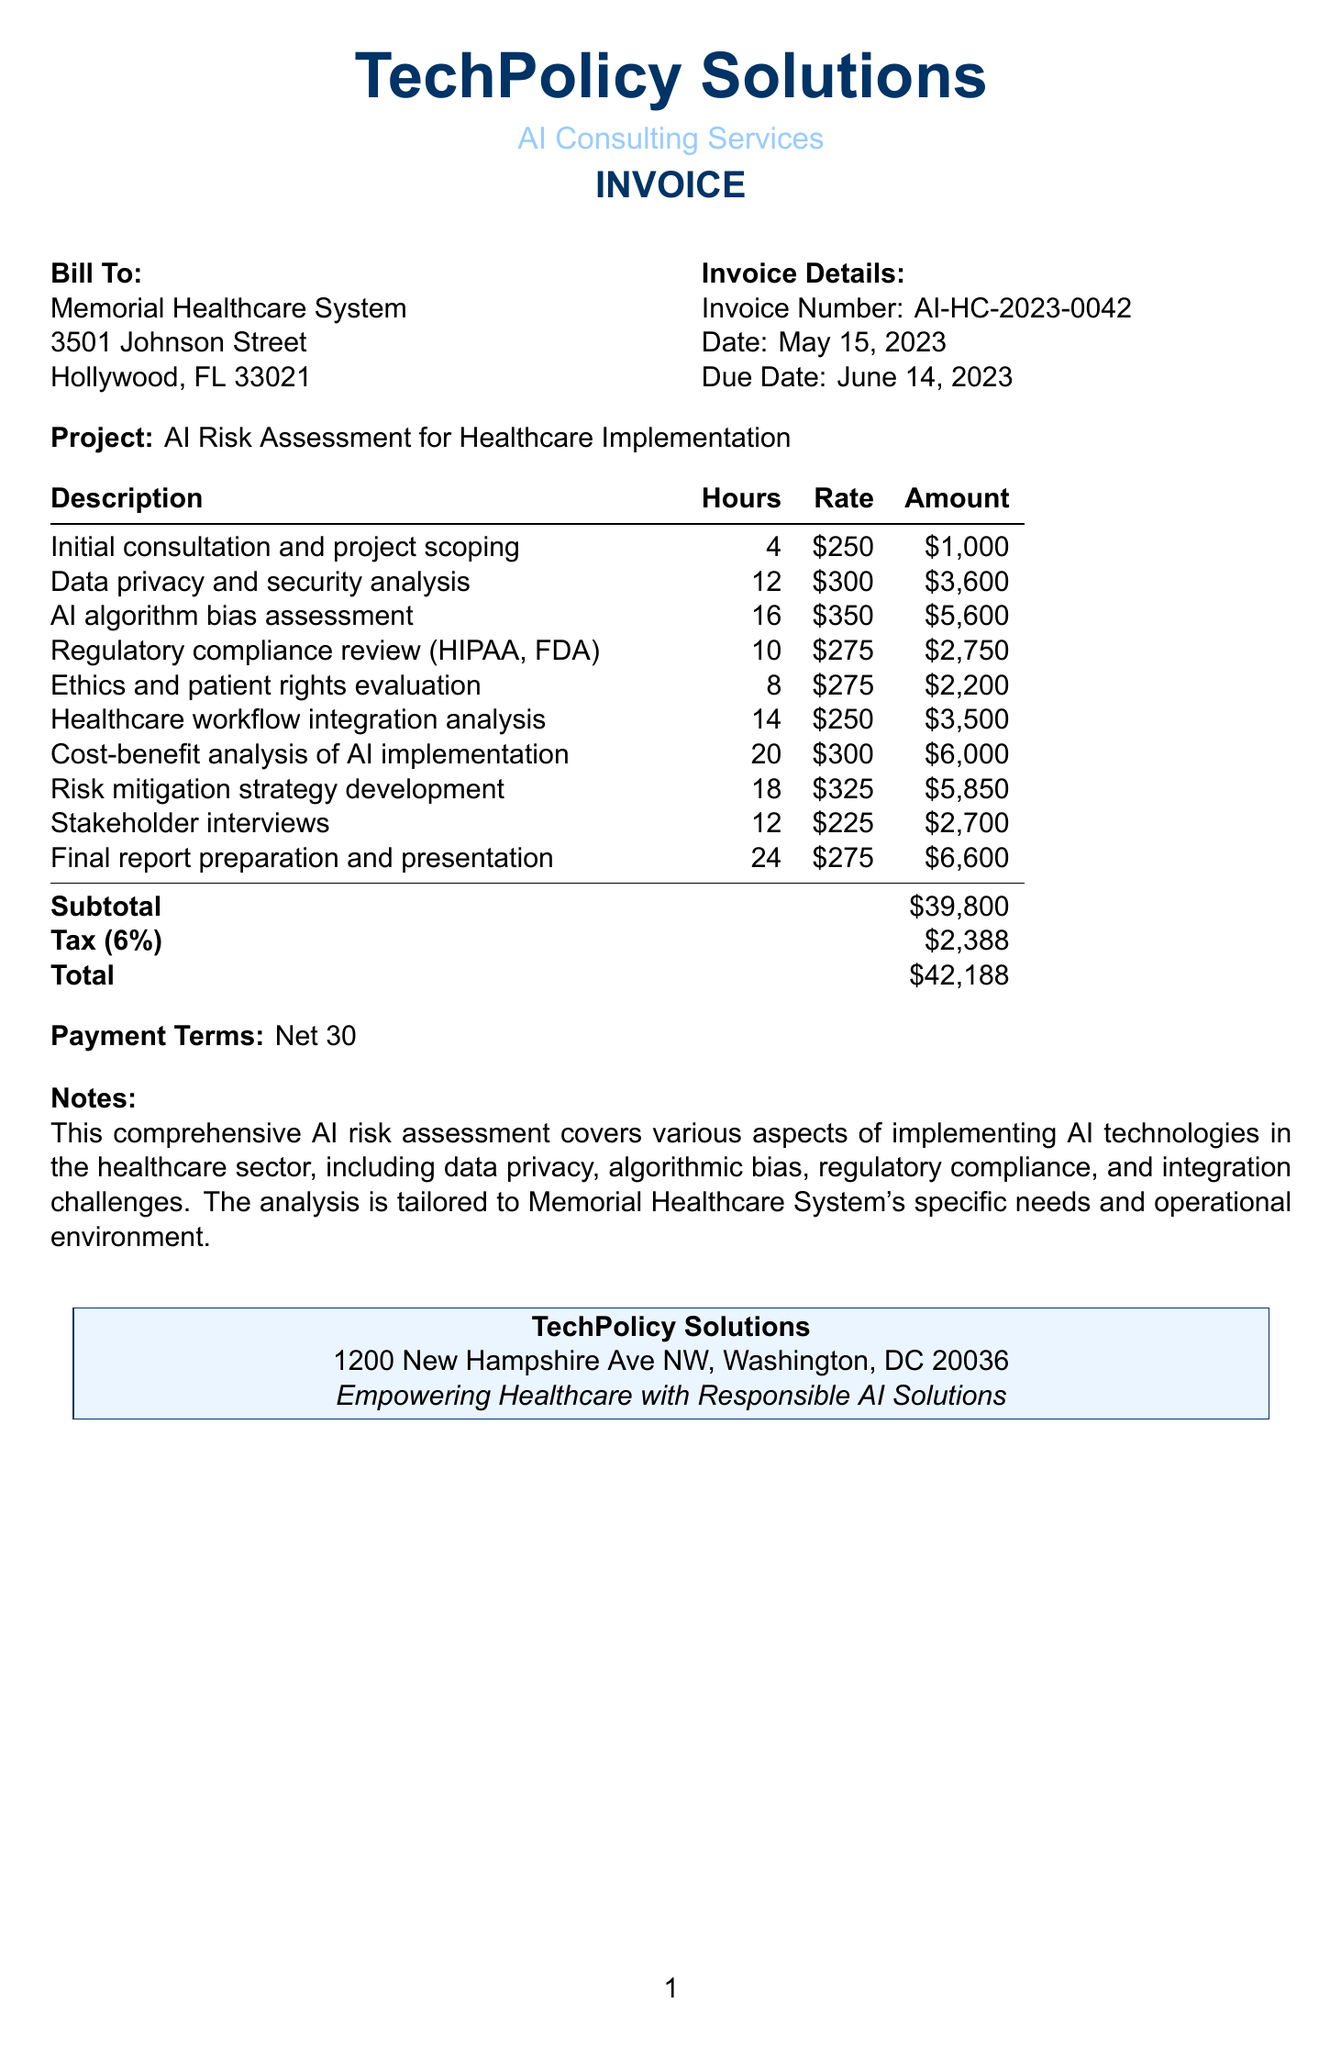What is the invoice number? The invoice number is a unique identifier for the document, which is specified in the invoice section.
Answer: AI-HC-2023-0042 Who is the client? The client is mentioned in the "Bill To" section, which specifies the recipient of the invoice.
Answer: Memorial Healthcare System What is the due date? The due date is provided in the invoice details section, indicating the payment deadline.
Answer: June 14, 2023 How many hours were spent on "Data privacy and security analysis"? The number of hours for each service is listed in the line items table.
Answer: 12 What is the total amount billed? The total amount is calculated including all services and applicable taxes, listed at the end of the invoice.
Answer: $42,188 What rate was charged for the "AI algorithm bias assessment"? The rate for each service is specified in the line items with each corresponding description.
Answer: $350 What is the subtotal before tax? The subtotal is the cumulative sum of all amounts before taxes, as noted at the end of the tabulated amounts.
Answer: $39,800 What type of analysis covers "Ethics and patient rights evaluation"? This description outlines the scope of the analysis focusing on ethical considerations in implementing AI.
Answer: Ethics and patient rights evaluation What are the payment terms? The payment terms are specified clearly in the invoice, indicating how long the client has to pay the invoice amount.
Answer: Net 30 